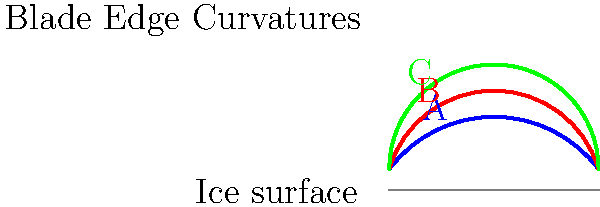Based on the cross-sectional diagrams of ice skate blade edges shown above, which curvature (A, B, or C) would likely provide the best balance between speed and maneuverability for a competitive junior ice skater? Explain your reasoning considering factors such as edge grip, turning ability, and friction. To determine the optimal blade edge curvature for a competitive junior ice skater, we need to consider several factors:

1. Edge grip: A sharper curve provides better grip on the ice, which is crucial for jumps and quick turns.
2. Turning ability: A more pronounced curve allows for tighter turns and better control during complex maneuvers.
3. Friction: A flatter curve reduces friction, allowing for higher speeds on straightaways.
4. Skater's skill level: Junior skaters need a balance between control and speed as they develop their techniques.

Analyzing the given curves:

A (Blue): The flattest curve, which would provide the least friction and highest speed, but also the least grip and turning ability.
B (Red): A moderate curve, offering a balance between speed and control.
C (Green): The sharpest curve, providing the best grip and turning ability, but also the most friction and potentially lower speed.

For a competitive junior ice skater:
- They need good control for executing jumps and spins, which requires sufficient edge grip.
- They also need to perform complex footwork and transitions, necessitating good turning ability.
- While speed is important, it's not as critical as control at this level.

Considering these factors, curve B (Red) would likely provide the best balance. It offers:
- Moderate edge grip for jumps and spins
- Good turning ability for footwork and transitions
- Reduced friction compared to curve C, allowing for decent speed

This curvature allows junior skaters to develop their skills across various aspects of figure skating while providing a good foundation for future advancement.
Answer: B (Red curve) 